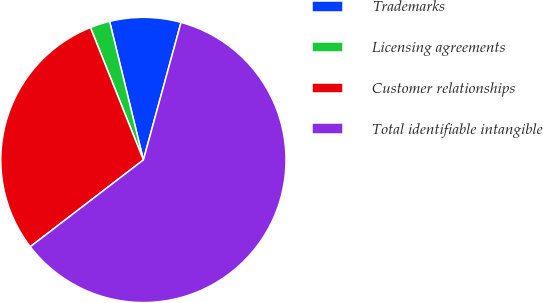Convert chart to OTSL. <chart><loc_0><loc_0><loc_500><loc_500><pie_chart><fcel>Trademarks<fcel>Licensing agreements<fcel>Customer relationships<fcel>Total identifiable intangible<nl><fcel>8.06%<fcel>2.25%<fcel>29.36%<fcel>60.34%<nl></chart> 